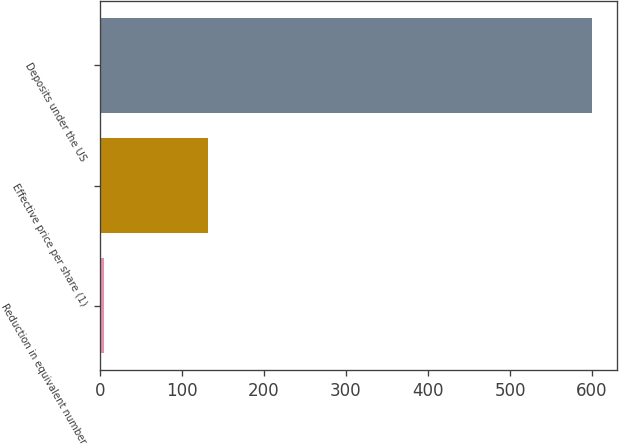Convert chart to OTSL. <chart><loc_0><loc_0><loc_500><loc_500><bar_chart><fcel>Reduction in equivalent number<fcel>Effective price per share (1)<fcel>Deposits under the US<nl><fcel>5<fcel>132.32<fcel>600<nl></chart> 